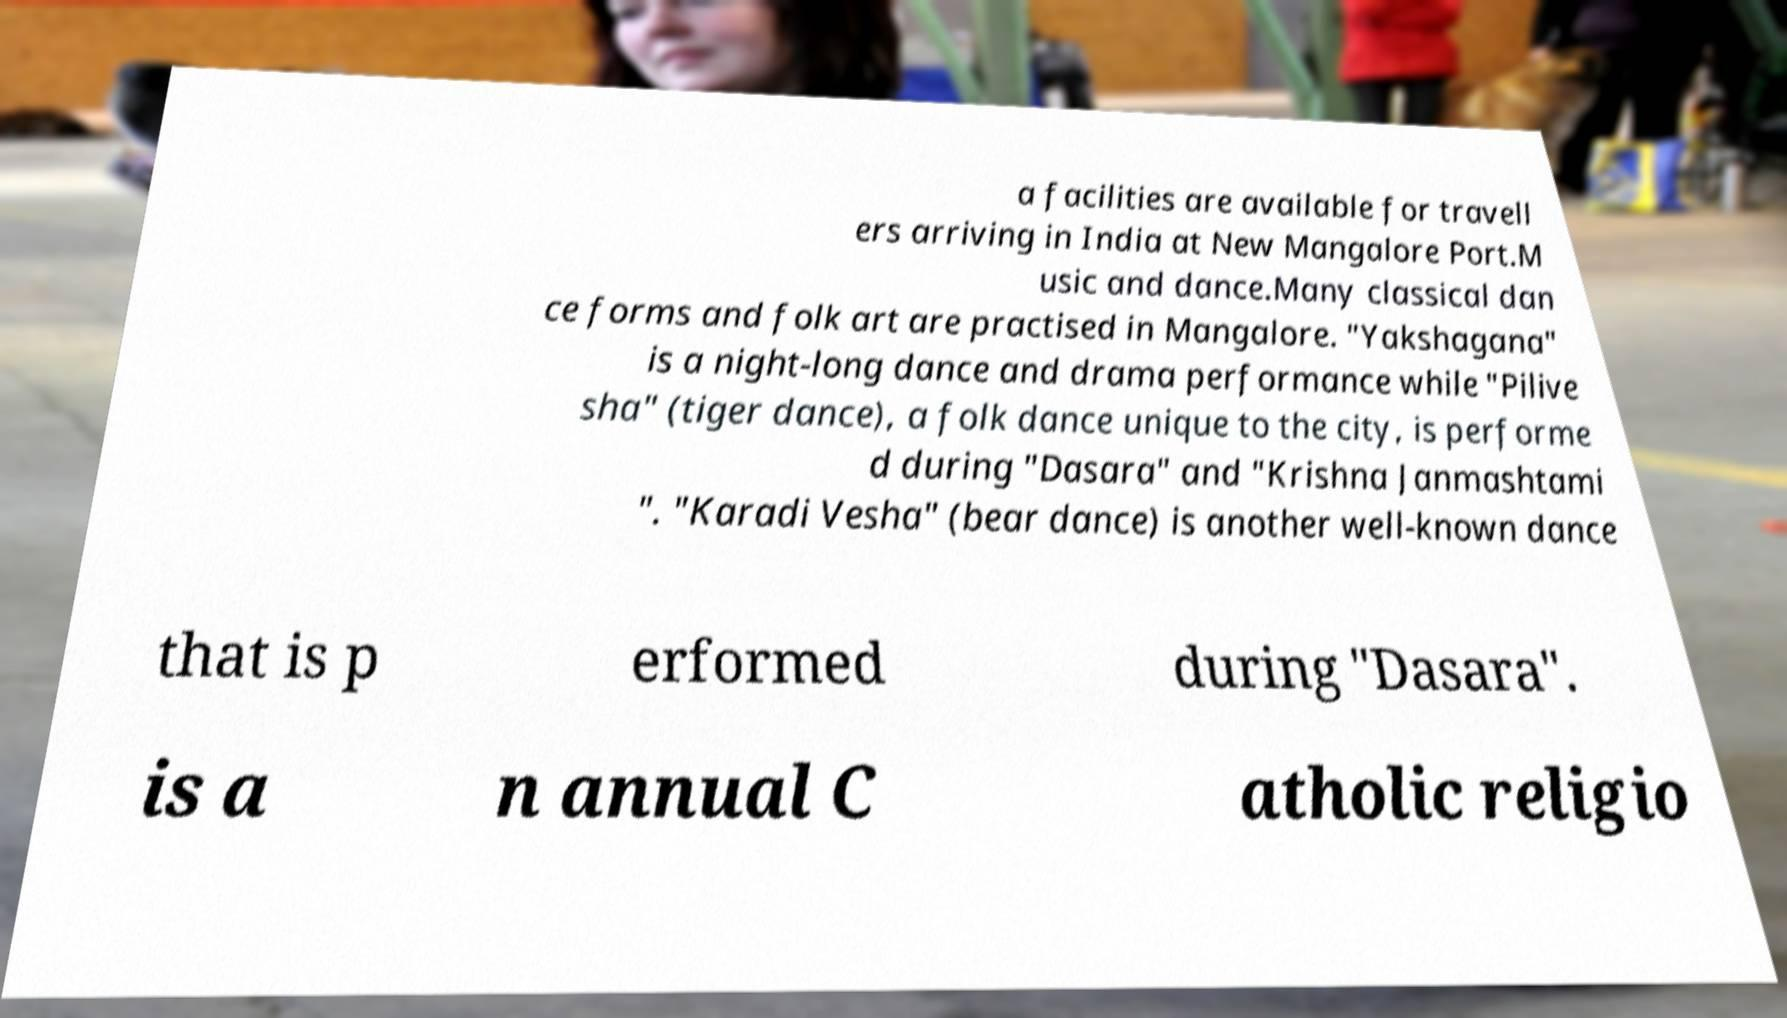I need the written content from this picture converted into text. Can you do that? a facilities are available for travell ers arriving in India at New Mangalore Port.M usic and dance.Many classical dan ce forms and folk art are practised in Mangalore. "Yakshagana" is a night-long dance and drama performance while "Pilive sha" (tiger dance), a folk dance unique to the city, is performe d during "Dasara" and "Krishna Janmashtami ". "Karadi Vesha" (bear dance) is another well-known dance that is p erformed during "Dasara". is a n annual C atholic religio 